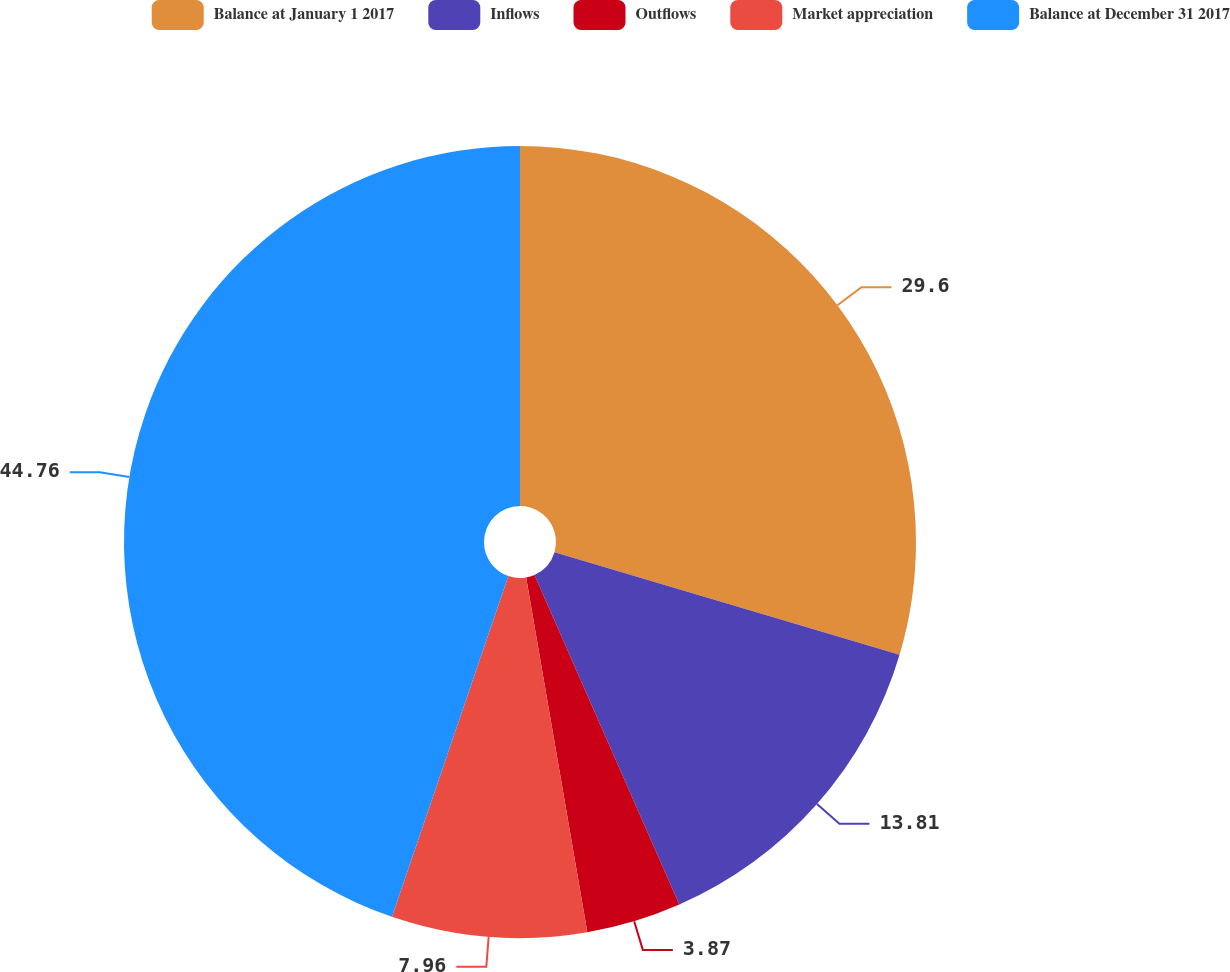<chart> <loc_0><loc_0><loc_500><loc_500><pie_chart><fcel>Balance at January 1 2017<fcel>Inflows<fcel>Outflows<fcel>Market appreciation<fcel>Balance at December 31 2017<nl><fcel>29.6%<fcel>13.81%<fcel>3.87%<fcel>7.96%<fcel>44.76%<nl></chart> 